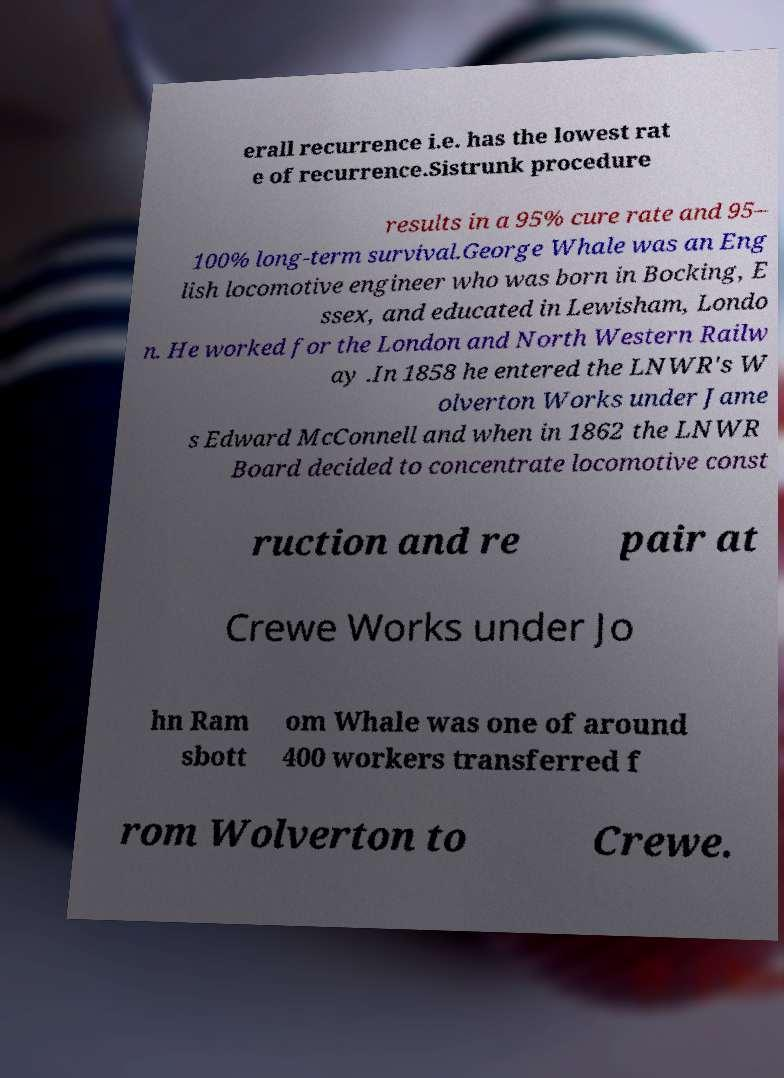Can you accurately transcribe the text from the provided image for me? erall recurrence i.e. has the lowest rat e of recurrence.Sistrunk procedure results in a 95% cure rate and 95– 100% long-term survival.George Whale was an Eng lish locomotive engineer who was born in Bocking, E ssex, and educated in Lewisham, Londo n. He worked for the London and North Western Railw ay .In 1858 he entered the LNWR's W olverton Works under Jame s Edward McConnell and when in 1862 the LNWR Board decided to concentrate locomotive const ruction and re pair at Crewe Works under Jo hn Ram sbott om Whale was one of around 400 workers transferred f rom Wolverton to Crewe. 